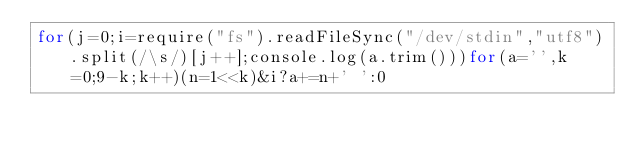<code> <loc_0><loc_0><loc_500><loc_500><_JavaScript_>for(j=0;i=require("fs").readFileSync("/dev/stdin","utf8").split(/\s/)[j++];console.log(a.trim()))for(a='',k=0;9-k;k++)(n=1<<k)&i?a+=n+' ':0</code> 